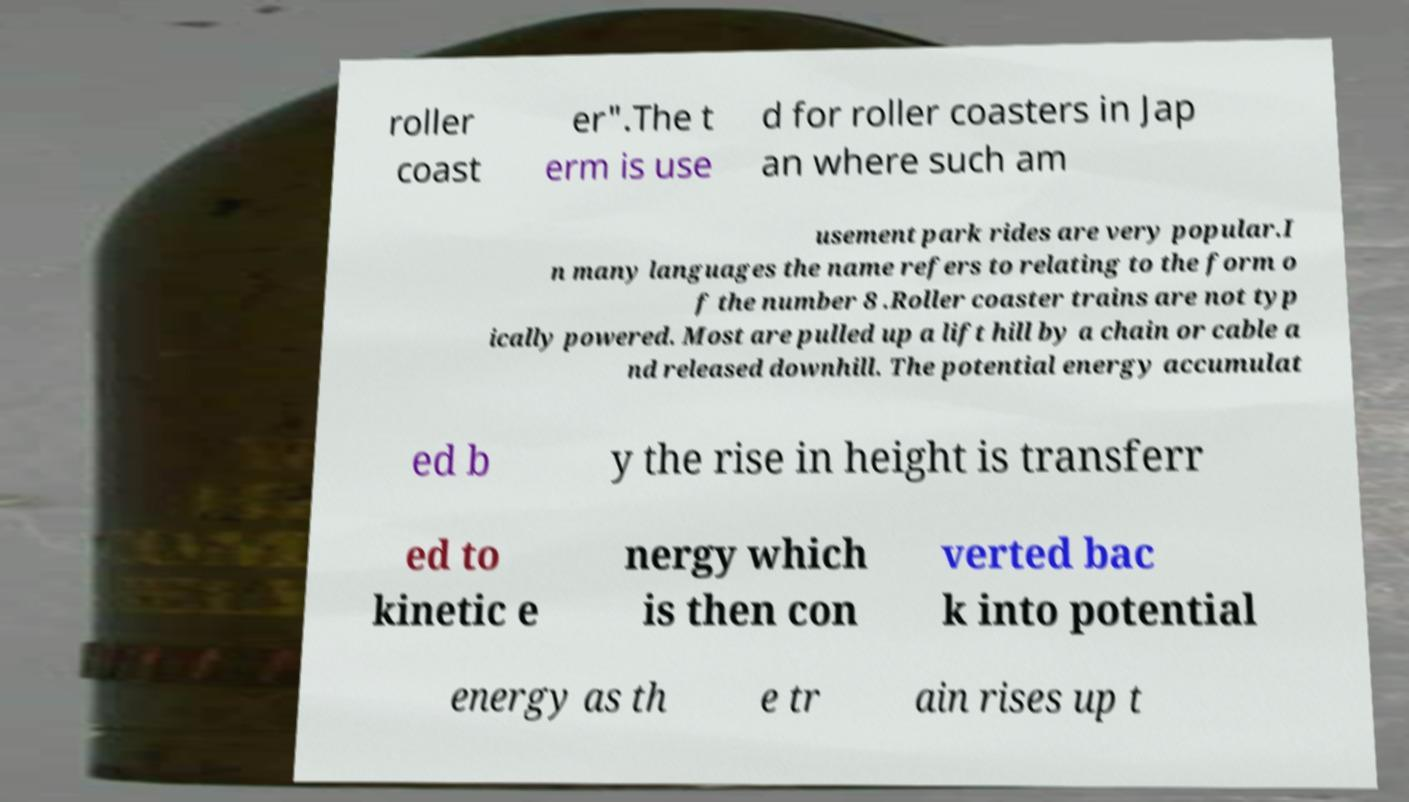Please read and relay the text visible in this image. What does it say? roller coast er".The t erm is use d for roller coasters in Jap an where such am usement park rides are very popular.I n many languages the name refers to relating to the form o f the number 8 .Roller coaster trains are not typ ically powered. Most are pulled up a lift hill by a chain or cable a nd released downhill. The potential energy accumulat ed b y the rise in height is transferr ed to kinetic e nergy which is then con verted bac k into potential energy as th e tr ain rises up t 